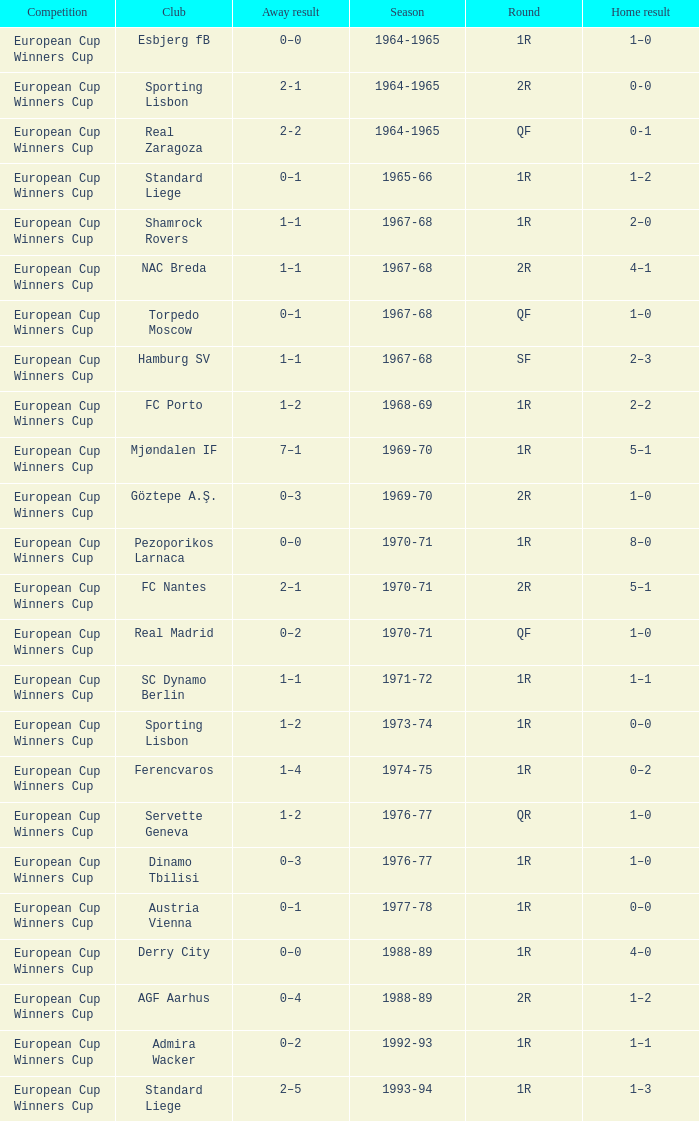Away result of 0–3, and a Season of 1969-70 is what competition? European Cup Winners Cup. 